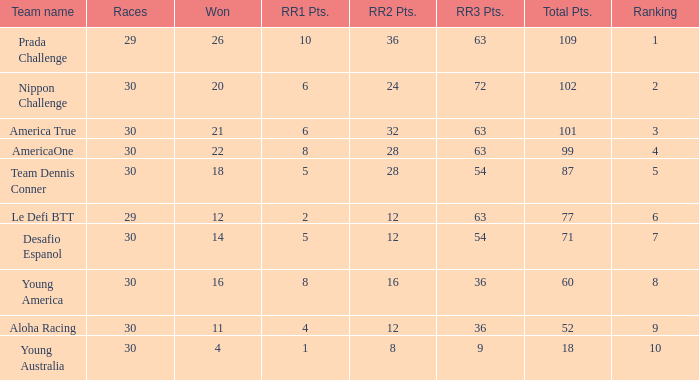Identify the rank of rr2 points when equal to 10.0. 